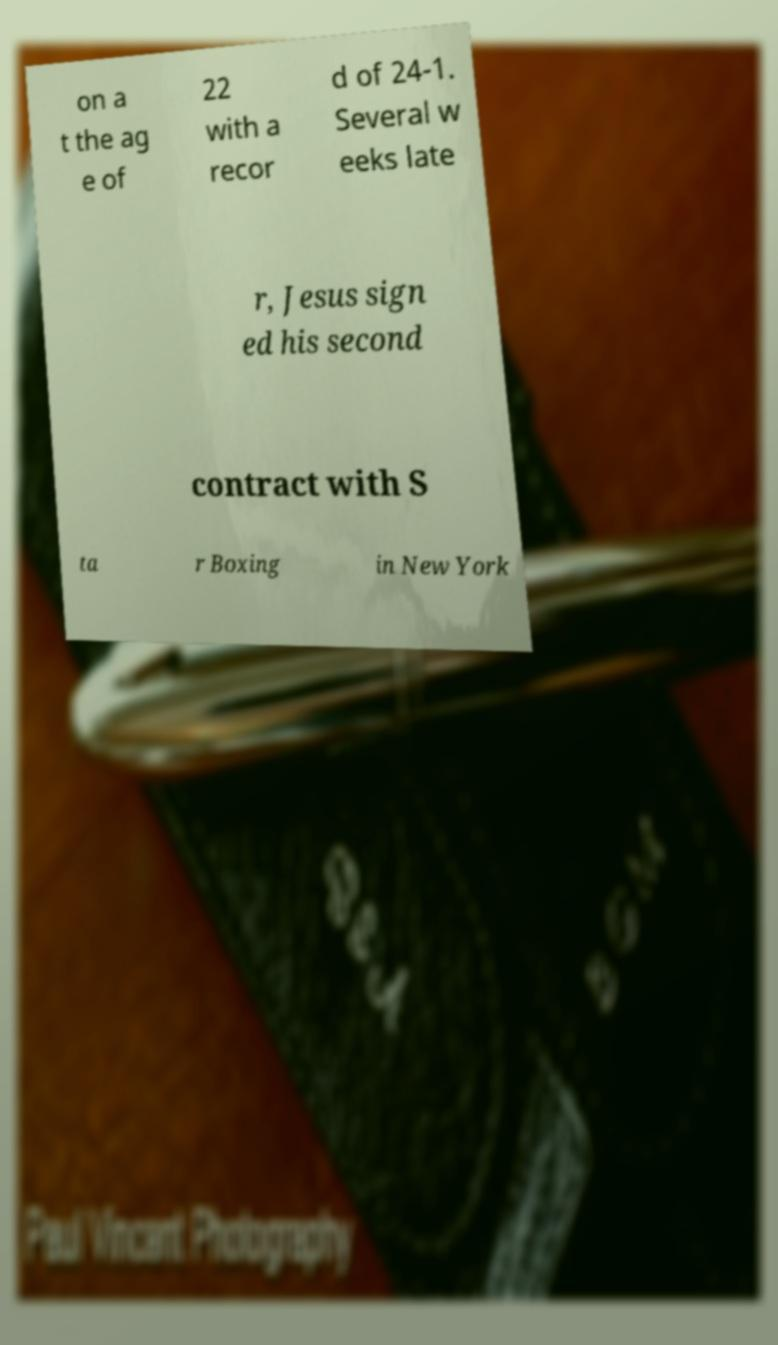There's text embedded in this image that I need extracted. Can you transcribe it verbatim? on a t the ag e of 22 with a recor d of 24-1. Several w eeks late r, Jesus sign ed his second contract with S ta r Boxing in New York 